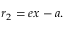<formula> <loc_0><loc_0><loc_500><loc_500>r _ { 2 } = e x - a . \,</formula> 